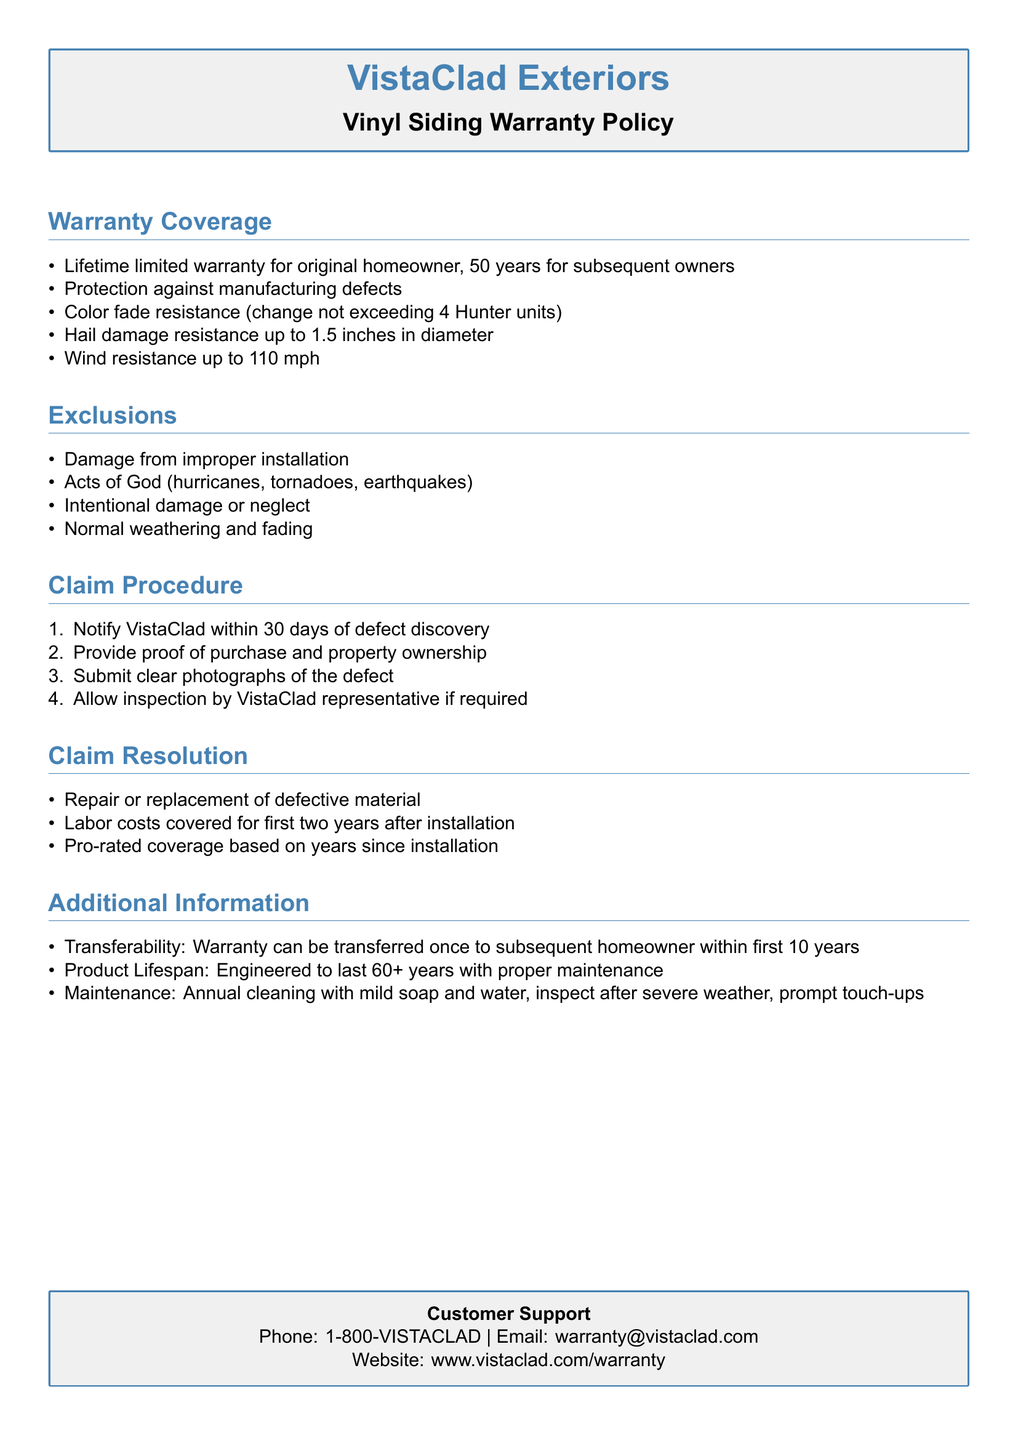What is the warranty duration for the original homeowner? The warranty duration for the original homeowner is specified in the document.
Answer: Lifetime limited warranty What is the coverage for hail damage? Hail damage coverage is detailed in the coverage section of the document.
Answer: Up to 1.5 inches in diameter What must a customer do within 30 days of discovering a defect? This action is outlined in the claim procedure section of the document.
Answer: Notify VistaClad What is the maximum wind resistance specified? This information can be found in the warranty coverage section.
Answer: Up to 110 mph What is the product lifespan guarantee? The lifespan guarantee is mentioned in the additional information section of the document.
Answer: 60+ years Which event types are excluded from the warranty? The exclusions section lists these event types specifically.
Answer: Acts of God What items are covered regarding labor costs after installation? The claim resolution section states the labor coverage terms.
Answer: For first two years How many times can the warranty be transferred? This detail about transferability is present in the additional information section.
Answer: Once What is the contact phone number for customer support? This information is provided in the customer support section of the document.
Answer: 1-800-VISTACLAD 